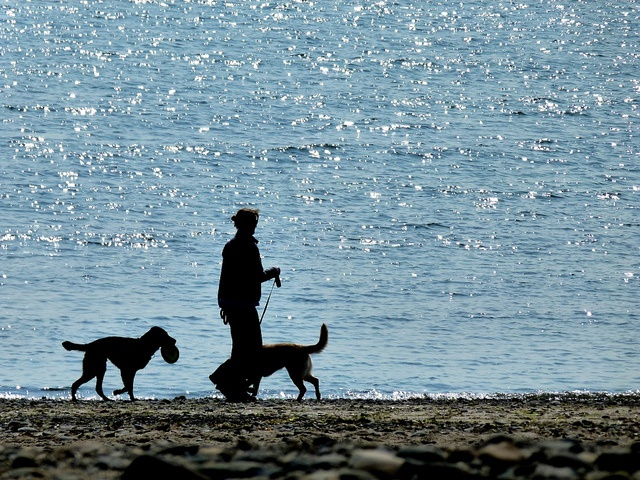Describe the objects in this image and their specific colors. I can see people in lightblue, black, darkgray, and gray tones, dog in lightblue, black, gray, and darkgray tones, dog in lightblue, black, gray, and darkgray tones, and frisbee in lightblue, black, purple, teal, and darkblue tones in this image. 